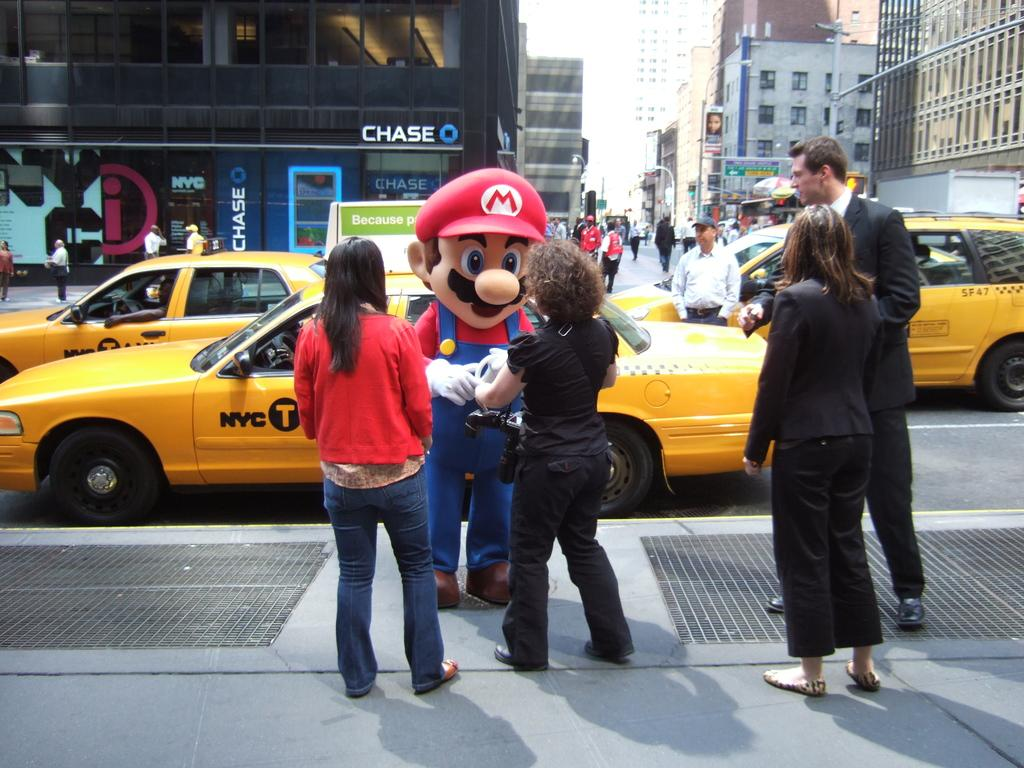<image>
Write a terse but informative summary of the picture. A person dressed up in a Mario costume standing in front of a NYC Taxi. 